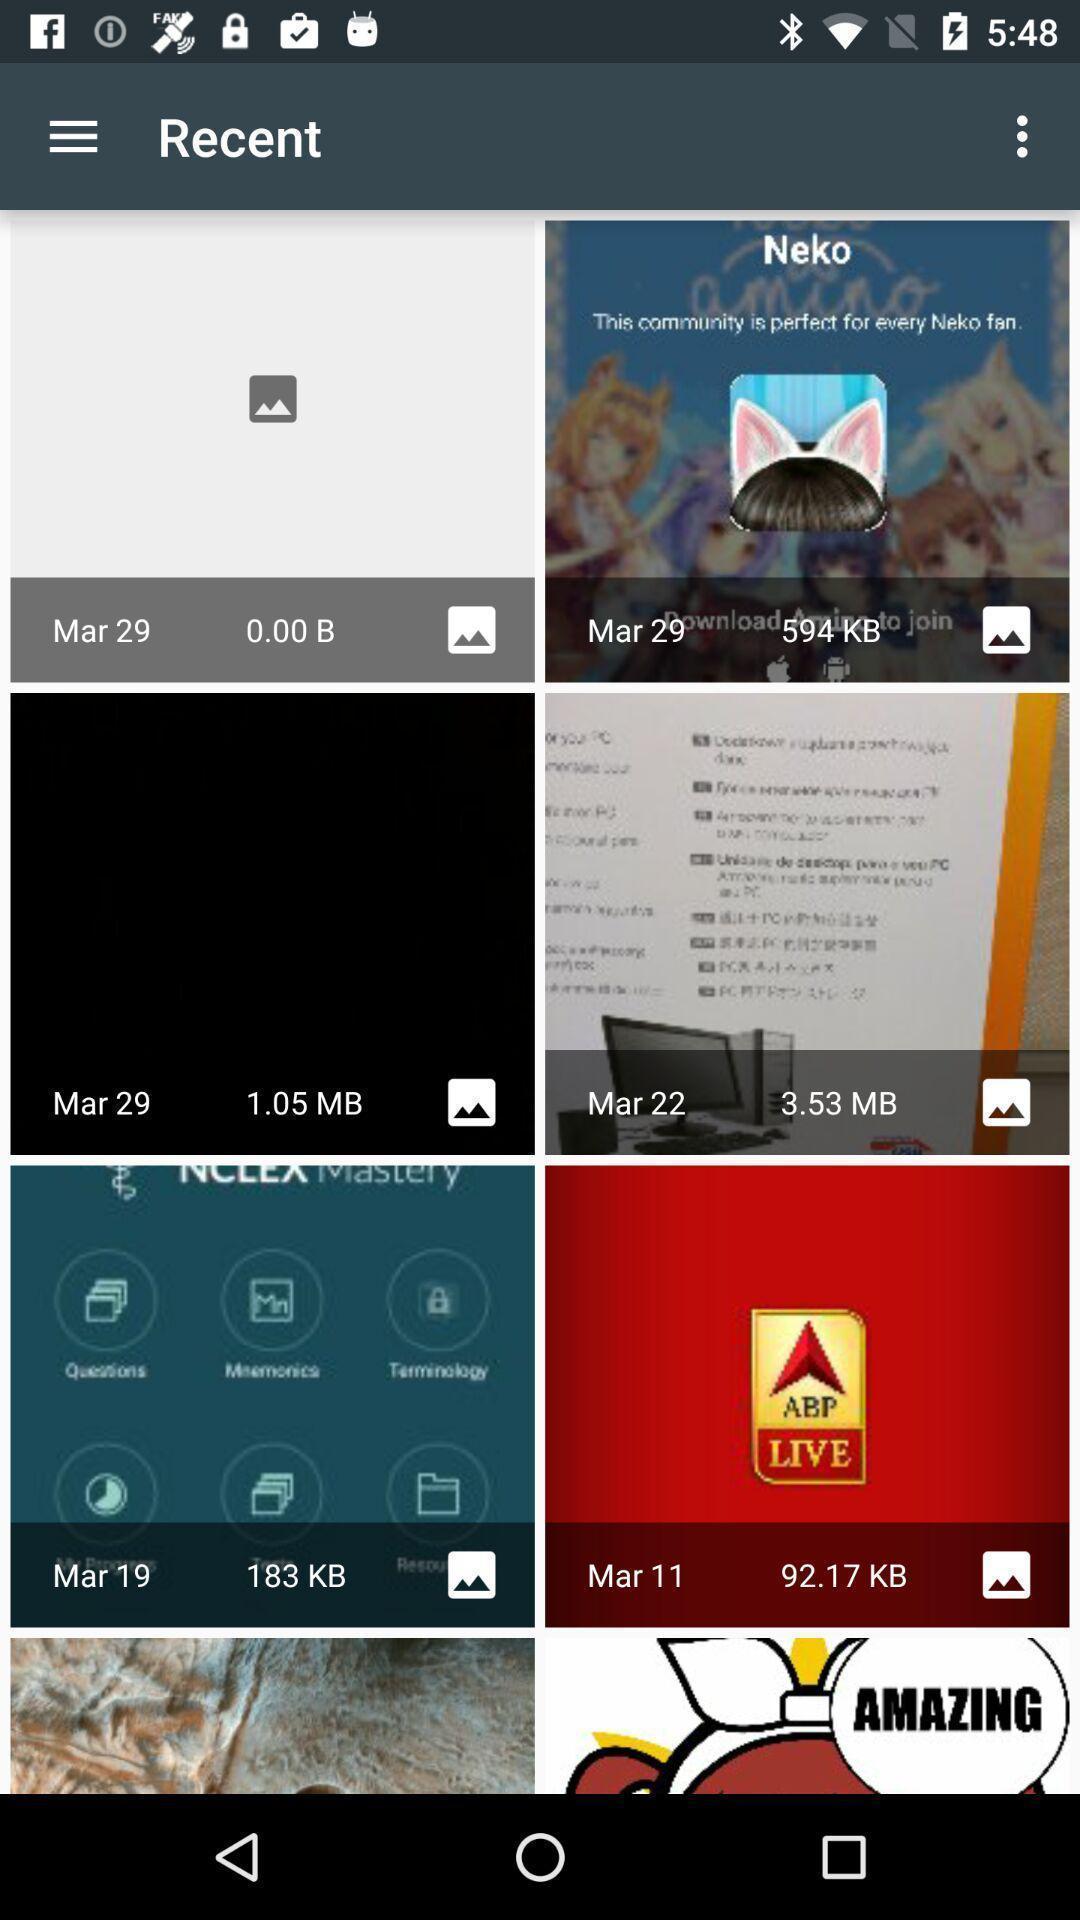Explain what's happening in this screen capture. Screen shows recent images in gallery application. 